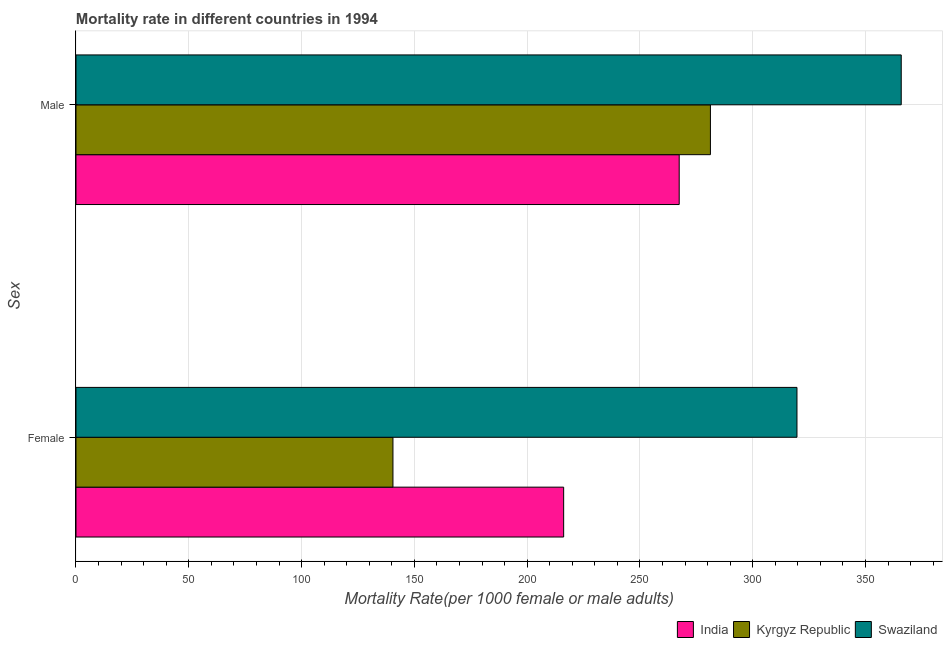How many different coloured bars are there?
Provide a short and direct response. 3. Are the number of bars per tick equal to the number of legend labels?
Make the answer very short. Yes. Are the number of bars on each tick of the Y-axis equal?
Offer a very short reply. Yes. How many bars are there on the 1st tick from the bottom?
Your answer should be very brief. 3. What is the male mortality rate in Swaziland?
Your answer should be compact. 365.86. Across all countries, what is the maximum female mortality rate?
Your answer should be compact. 319.63. Across all countries, what is the minimum male mortality rate?
Your answer should be very brief. 267.43. In which country was the male mortality rate maximum?
Ensure brevity in your answer.  Swaziland. In which country was the female mortality rate minimum?
Offer a very short reply. Kyrgyz Republic. What is the total male mortality rate in the graph?
Provide a succinct answer. 914.55. What is the difference between the male mortality rate in Kyrgyz Republic and that in Swaziland?
Offer a terse response. -84.59. What is the difference between the female mortality rate in Swaziland and the male mortality rate in Kyrgyz Republic?
Give a very brief answer. 38.37. What is the average female mortality rate per country?
Make the answer very short. 225.45. What is the difference between the female mortality rate and male mortality rate in Kyrgyz Republic?
Provide a short and direct response. -140.75. What is the ratio of the female mortality rate in Swaziland to that in Kyrgyz Republic?
Your answer should be very brief. 2.27. Is the female mortality rate in Kyrgyz Republic less than that in India?
Your answer should be very brief. Yes. What does the 1st bar from the top in Male represents?
Your response must be concise. Swaziland. What does the 3rd bar from the bottom in Female represents?
Offer a terse response. Swaziland. Does the graph contain any zero values?
Offer a very short reply. No. Does the graph contain grids?
Offer a terse response. Yes. How are the legend labels stacked?
Your answer should be very brief. Horizontal. What is the title of the graph?
Your answer should be very brief. Mortality rate in different countries in 1994. What is the label or title of the X-axis?
Offer a very short reply. Mortality Rate(per 1000 female or male adults). What is the label or title of the Y-axis?
Your response must be concise. Sex. What is the Mortality Rate(per 1000 female or male adults) of India in Female?
Ensure brevity in your answer.  216.2. What is the Mortality Rate(per 1000 female or male adults) of Kyrgyz Republic in Female?
Provide a short and direct response. 140.52. What is the Mortality Rate(per 1000 female or male adults) of Swaziland in Female?
Provide a short and direct response. 319.63. What is the Mortality Rate(per 1000 female or male adults) in India in Male?
Keep it short and to the point. 267.43. What is the Mortality Rate(per 1000 female or male adults) of Kyrgyz Republic in Male?
Provide a succinct answer. 281.27. What is the Mortality Rate(per 1000 female or male adults) in Swaziland in Male?
Provide a succinct answer. 365.86. Across all Sex, what is the maximum Mortality Rate(per 1000 female or male adults) in India?
Your answer should be compact. 267.43. Across all Sex, what is the maximum Mortality Rate(per 1000 female or male adults) of Kyrgyz Republic?
Your response must be concise. 281.27. Across all Sex, what is the maximum Mortality Rate(per 1000 female or male adults) of Swaziland?
Ensure brevity in your answer.  365.86. Across all Sex, what is the minimum Mortality Rate(per 1000 female or male adults) in India?
Your answer should be compact. 216.2. Across all Sex, what is the minimum Mortality Rate(per 1000 female or male adults) of Kyrgyz Republic?
Offer a terse response. 140.52. Across all Sex, what is the minimum Mortality Rate(per 1000 female or male adults) in Swaziland?
Offer a very short reply. 319.63. What is the total Mortality Rate(per 1000 female or male adults) in India in the graph?
Keep it short and to the point. 483.63. What is the total Mortality Rate(per 1000 female or male adults) in Kyrgyz Republic in the graph?
Ensure brevity in your answer.  421.79. What is the total Mortality Rate(per 1000 female or male adults) of Swaziland in the graph?
Provide a short and direct response. 685.49. What is the difference between the Mortality Rate(per 1000 female or male adults) of India in Female and that in Male?
Keep it short and to the point. -51.23. What is the difference between the Mortality Rate(per 1000 female or male adults) of Kyrgyz Republic in Female and that in Male?
Give a very brief answer. -140.75. What is the difference between the Mortality Rate(per 1000 female or male adults) in Swaziland in Female and that in Male?
Ensure brevity in your answer.  -46.22. What is the difference between the Mortality Rate(per 1000 female or male adults) in India in Female and the Mortality Rate(per 1000 female or male adults) in Kyrgyz Republic in Male?
Your response must be concise. -65.07. What is the difference between the Mortality Rate(per 1000 female or male adults) in India in Female and the Mortality Rate(per 1000 female or male adults) in Swaziland in Male?
Your response must be concise. -149.66. What is the difference between the Mortality Rate(per 1000 female or male adults) in Kyrgyz Republic in Female and the Mortality Rate(per 1000 female or male adults) in Swaziland in Male?
Your answer should be very brief. -225.34. What is the average Mortality Rate(per 1000 female or male adults) of India per Sex?
Offer a very short reply. 241.81. What is the average Mortality Rate(per 1000 female or male adults) in Kyrgyz Republic per Sex?
Provide a short and direct response. 210.89. What is the average Mortality Rate(per 1000 female or male adults) in Swaziland per Sex?
Offer a very short reply. 342.75. What is the difference between the Mortality Rate(per 1000 female or male adults) of India and Mortality Rate(per 1000 female or male adults) of Kyrgyz Republic in Female?
Make the answer very short. 75.68. What is the difference between the Mortality Rate(per 1000 female or male adults) of India and Mortality Rate(per 1000 female or male adults) of Swaziland in Female?
Keep it short and to the point. -103.43. What is the difference between the Mortality Rate(per 1000 female or male adults) of Kyrgyz Republic and Mortality Rate(per 1000 female or male adults) of Swaziland in Female?
Provide a short and direct response. -179.11. What is the difference between the Mortality Rate(per 1000 female or male adults) in India and Mortality Rate(per 1000 female or male adults) in Kyrgyz Republic in Male?
Offer a terse response. -13.84. What is the difference between the Mortality Rate(per 1000 female or male adults) in India and Mortality Rate(per 1000 female or male adults) in Swaziland in Male?
Offer a terse response. -98.43. What is the difference between the Mortality Rate(per 1000 female or male adults) of Kyrgyz Republic and Mortality Rate(per 1000 female or male adults) of Swaziland in Male?
Your answer should be compact. -84.59. What is the ratio of the Mortality Rate(per 1000 female or male adults) in India in Female to that in Male?
Offer a very short reply. 0.81. What is the ratio of the Mortality Rate(per 1000 female or male adults) of Kyrgyz Republic in Female to that in Male?
Ensure brevity in your answer.  0.5. What is the ratio of the Mortality Rate(per 1000 female or male adults) in Swaziland in Female to that in Male?
Your response must be concise. 0.87. What is the difference between the highest and the second highest Mortality Rate(per 1000 female or male adults) in India?
Your response must be concise. 51.23. What is the difference between the highest and the second highest Mortality Rate(per 1000 female or male adults) of Kyrgyz Republic?
Offer a very short reply. 140.75. What is the difference between the highest and the second highest Mortality Rate(per 1000 female or male adults) in Swaziland?
Offer a very short reply. 46.22. What is the difference between the highest and the lowest Mortality Rate(per 1000 female or male adults) in India?
Offer a terse response. 51.23. What is the difference between the highest and the lowest Mortality Rate(per 1000 female or male adults) of Kyrgyz Republic?
Ensure brevity in your answer.  140.75. What is the difference between the highest and the lowest Mortality Rate(per 1000 female or male adults) of Swaziland?
Provide a short and direct response. 46.22. 